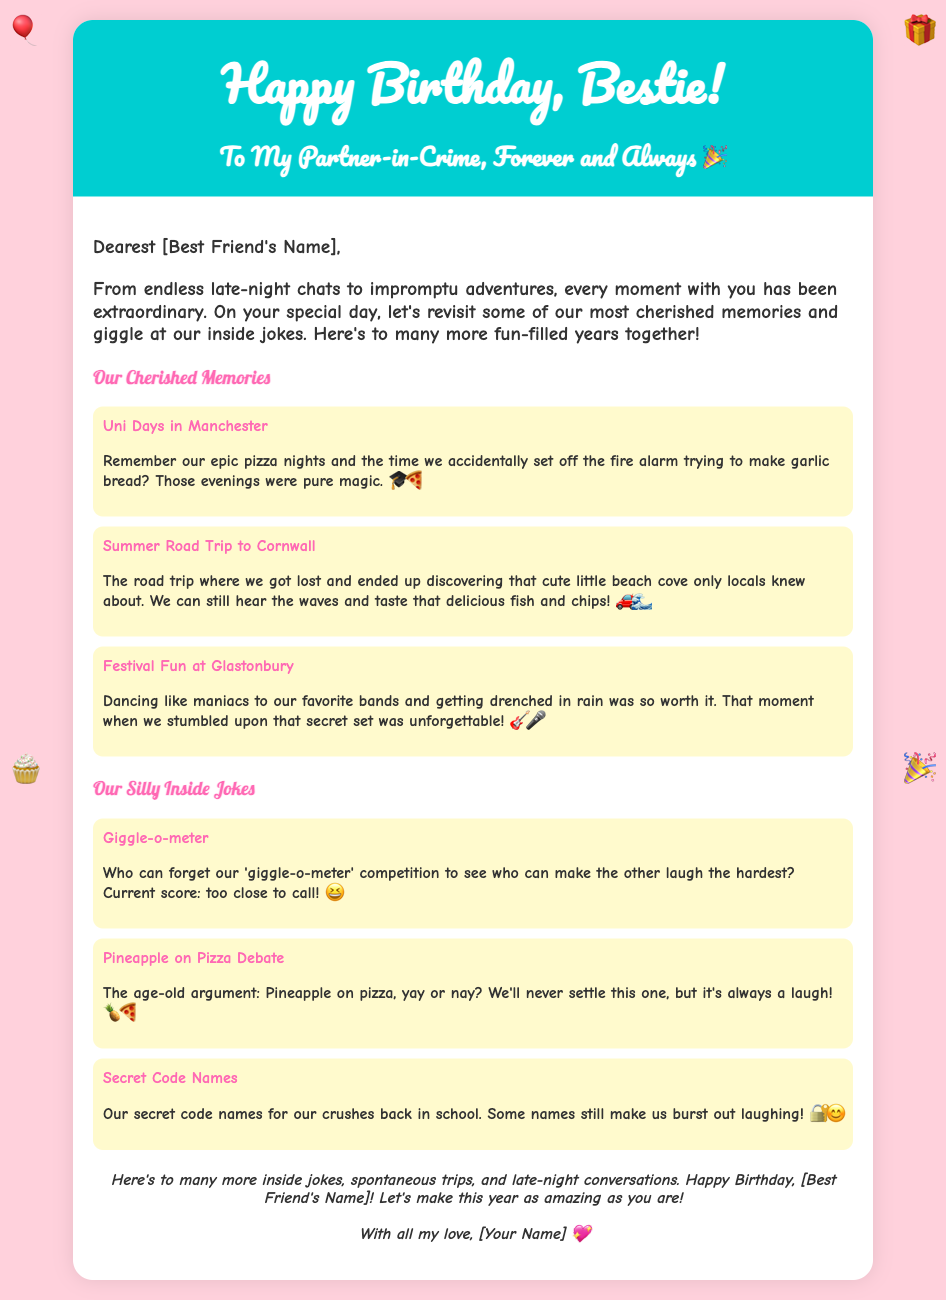what is the title of the greeting card? The title of the greeting card is located in the header section, which states "Happy Birthday, Bestie!"
Answer: Happy Birthday, Bestie! who is the card addressed to? The card is addressed to "[Best Friend's Name]," which is a placeholder for the addressee's name.
Answer: [Best Friend's Name] what color is the background of the card? The background color of the card is specified in the style section as #FFD1DC.
Answer: #FFD1DC how many cherished memories are listed? There are three cherished memories listed in the section titled "Our Cherished Memories."
Answer: three what is one of the inside jokes mentioned? One inside joke mentioned is "Giggle-o-meter."
Answer: Giggle-o-meter what style of font is used for the header? The header uses the "Pacifico" cursive font, as specified in the style section.
Answer: Pacifico what is the closing message of the card? The closing message includes a warm sentiment and best wishes, reiterating the birthday wishes.
Answer: Here's to many more inside jokes, spontaneous trips, and late-night conversations. Happy Birthday, [Best Friend's Name]! Let's make this year as amazing as you are! which emojis are used in the decoration? The decorations include four emojis: 🎈, 🎁, 🧁, and 🎉.
Answer: 🎈, 🎁, 🧁, 🎉 what color is the header background? The header background color is specified as #00CED1 in the style section.
Answer: #00CED1 